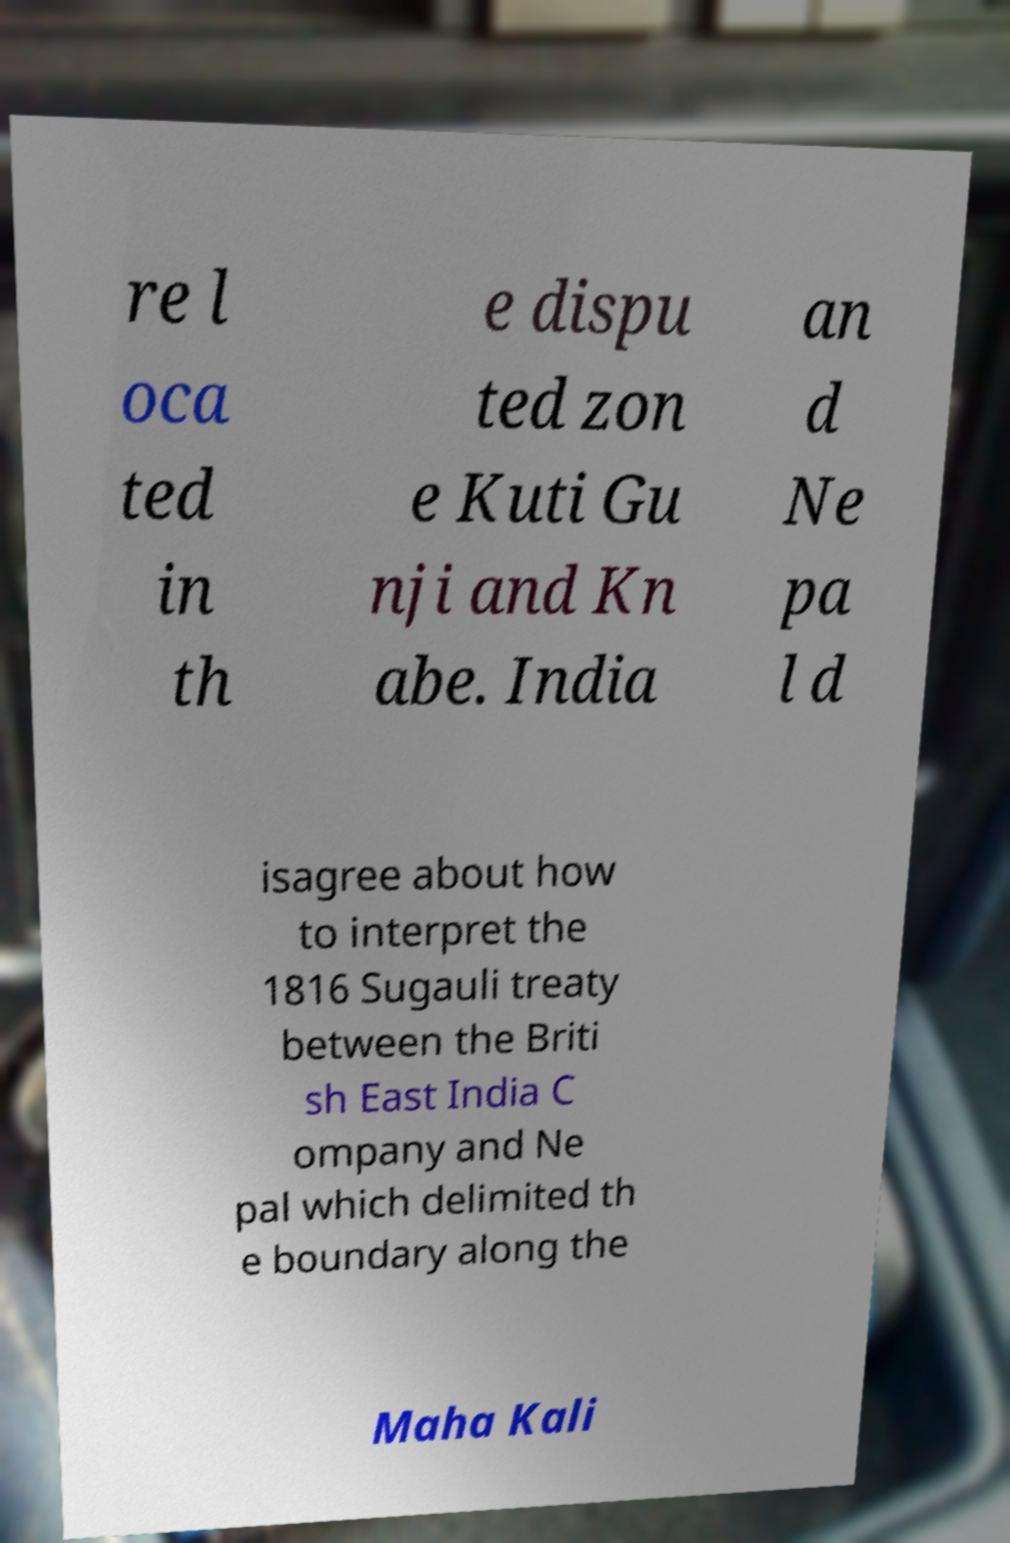Please read and relay the text visible in this image. What does it say? re l oca ted in th e dispu ted zon e Kuti Gu nji and Kn abe. India an d Ne pa l d isagree about how to interpret the 1816 Sugauli treaty between the Briti sh East India C ompany and Ne pal which delimited th e boundary along the Maha Kali 